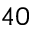<formula> <loc_0><loc_0><loc_500><loc_500>4 0</formula> 